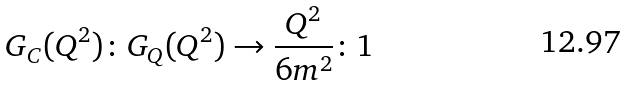Convert formula to latex. <formula><loc_0><loc_0><loc_500><loc_500>G _ { C } ( Q ^ { 2 } ) \colon G _ { Q } ( Q ^ { 2 } ) \rightarrow \frac { Q ^ { 2 } } { 6 m ^ { 2 } } \colon 1</formula> 